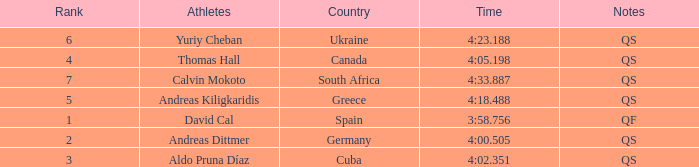What are the notes for the athlete from South Africa? QS. 